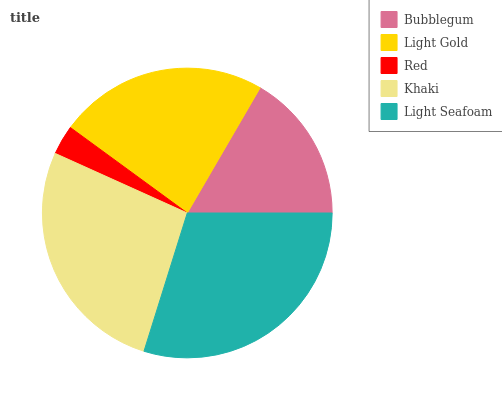Is Red the minimum?
Answer yes or no. Yes. Is Light Seafoam the maximum?
Answer yes or no. Yes. Is Light Gold the minimum?
Answer yes or no. No. Is Light Gold the maximum?
Answer yes or no. No. Is Light Gold greater than Bubblegum?
Answer yes or no. Yes. Is Bubblegum less than Light Gold?
Answer yes or no. Yes. Is Bubblegum greater than Light Gold?
Answer yes or no. No. Is Light Gold less than Bubblegum?
Answer yes or no. No. Is Light Gold the high median?
Answer yes or no. Yes. Is Light Gold the low median?
Answer yes or no. Yes. Is Khaki the high median?
Answer yes or no. No. Is Khaki the low median?
Answer yes or no. No. 